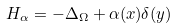<formula> <loc_0><loc_0><loc_500><loc_500>H _ { \alpha } = - \Delta _ { \Omega } + \alpha ( x ) \delta ( y )</formula> 